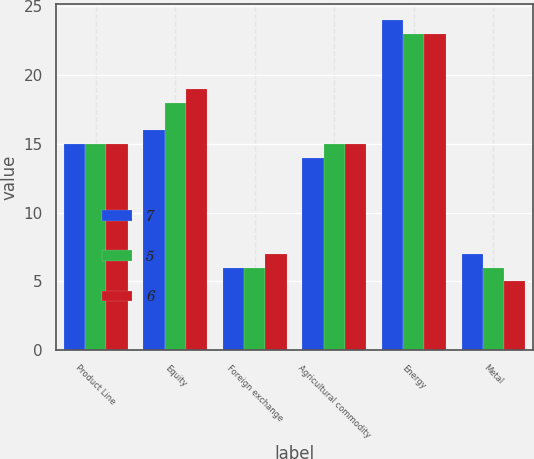<chart> <loc_0><loc_0><loc_500><loc_500><stacked_bar_chart><ecel><fcel>Product Line<fcel>Equity<fcel>Foreign exchange<fcel>Agricultural commodity<fcel>Energy<fcel>Metal<nl><fcel>7<fcel>15<fcel>16<fcel>6<fcel>14<fcel>24<fcel>7<nl><fcel>5<fcel>15<fcel>18<fcel>6<fcel>15<fcel>23<fcel>6<nl><fcel>6<fcel>15<fcel>19<fcel>7<fcel>15<fcel>23<fcel>5<nl></chart> 